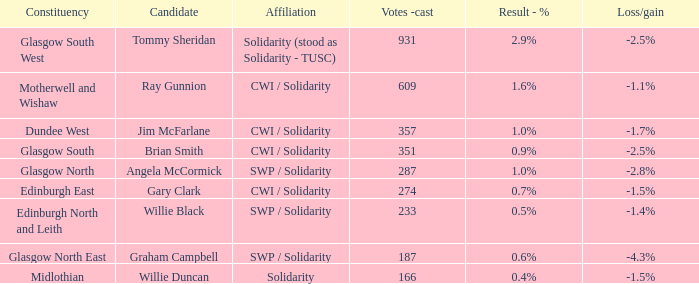What was the deficit/profit when the association was unity? -1.5%. 